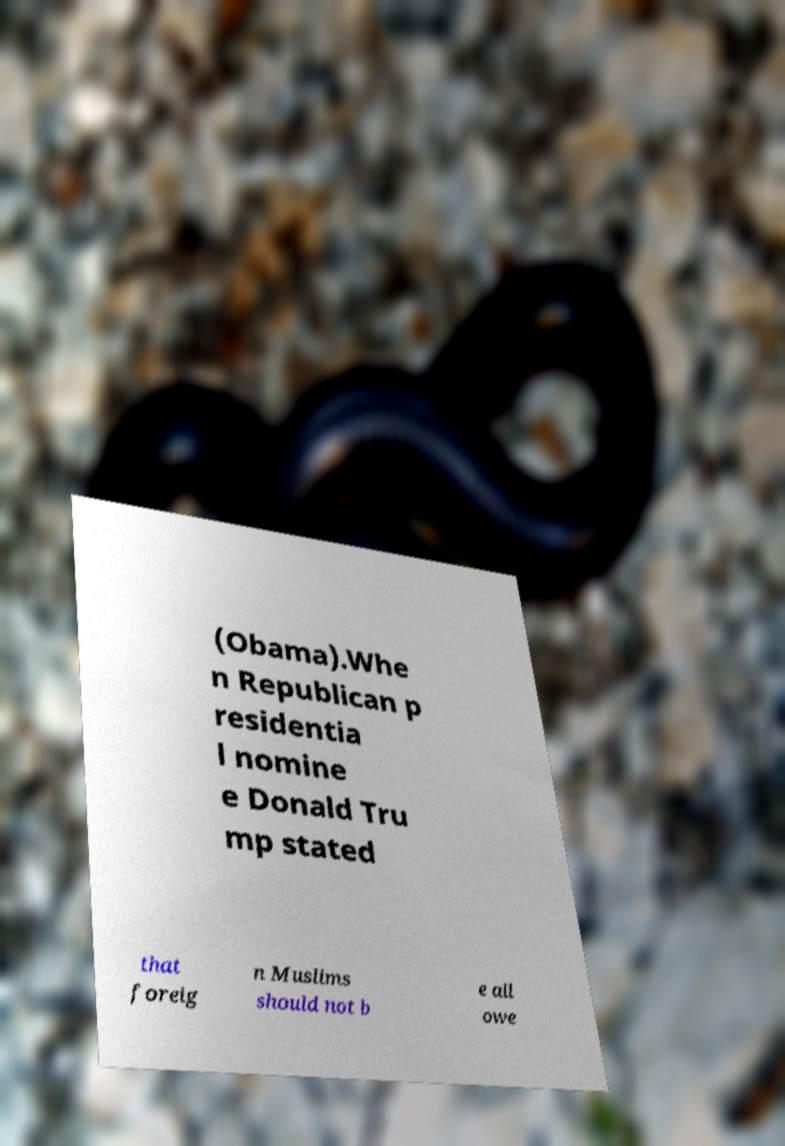Can you read and provide the text displayed in the image?This photo seems to have some interesting text. Can you extract and type it out for me? (Obama).Whe n Republican p residentia l nomine e Donald Tru mp stated that foreig n Muslims should not b e all owe 